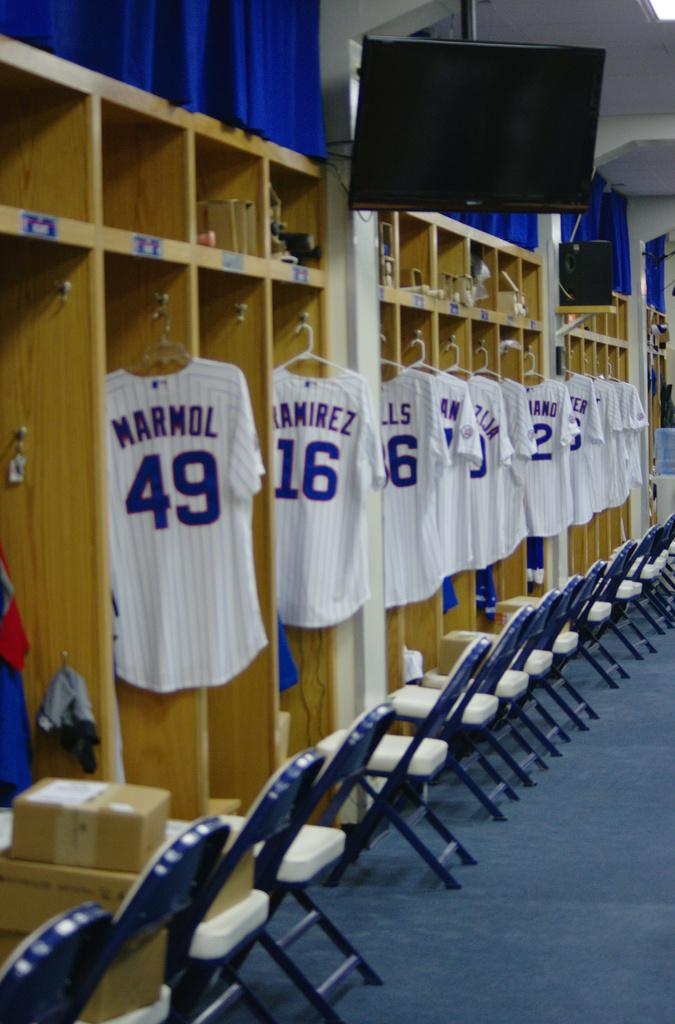<image>
Render a clear and concise summary of the photo. a few jerseys with numbers including the number49 